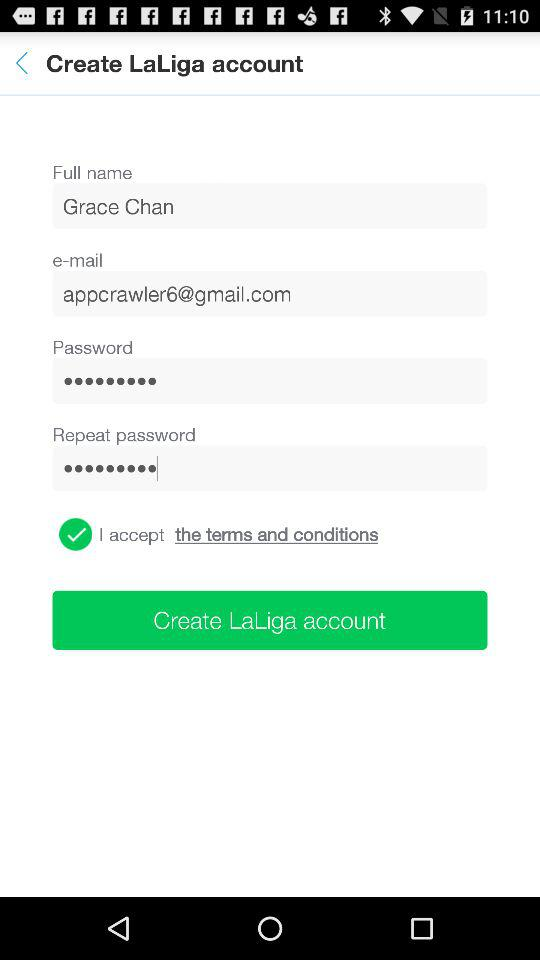What is the name of the user? The user name is Grace Chan. 